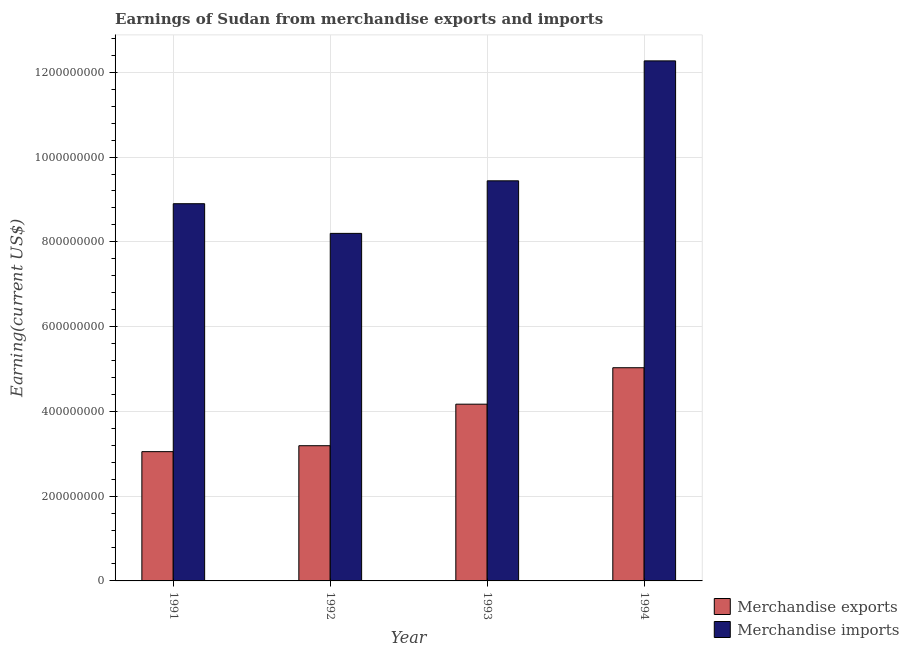How many groups of bars are there?
Provide a succinct answer. 4. Are the number of bars per tick equal to the number of legend labels?
Give a very brief answer. Yes. How many bars are there on the 4th tick from the right?
Provide a succinct answer. 2. What is the label of the 4th group of bars from the left?
Provide a short and direct response. 1994. What is the earnings from merchandise exports in 1993?
Provide a short and direct response. 4.17e+08. Across all years, what is the maximum earnings from merchandise exports?
Keep it short and to the point. 5.03e+08. Across all years, what is the minimum earnings from merchandise exports?
Offer a terse response. 3.05e+08. In which year was the earnings from merchandise exports maximum?
Offer a very short reply. 1994. What is the total earnings from merchandise exports in the graph?
Provide a short and direct response. 1.54e+09. What is the difference between the earnings from merchandise imports in 1991 and that in 1994?
Make the answer very short. -3.37e+08. What is the difference between the earnings from merchandise imports in 1991 and the earnings from merchandise exports in 1993?
Your answer should be compact. -5.40e+07. What is the average earnings from merchandise imports per year?
Provide a short and direct response. 9.70e+08. What is the ratio of the earnings from merchandise exports in 1993 to that in 1994?
Make the answer very short. 0.83. Is the earnings from merchandise exports in 1991 less than that in 1992?
Give a very brief answer. Yes. Is the difference between the earnings from merchandise exports in 1993 and 1994 greater than the difference between the earnings from merchandise imports in 1993 and 1994?
Provide a short and direct response. No. What is the difference between the highest and the second highest earnings from merchandise imports?
Ensure brevity in your answer.  2.83e+08. What is the difference between the highest and the lowest earnings from merchandise imports?
Your answer should be compact. 4.07e+08. Is the sum of the earnings from merchandise exports in 1993 and 1994 greater than the maximum earnings from merchandise imports across all years?
Your response must be concise. Yes. What does the 1st bar from the left in 1991 represents?
Your answer should be very brief. Merchandise exports. How many bars are there?
Ensure brevity in your answer.  8. What is the difference between two consecutive major ticks on the Y-axis?
Keep it short and to the point. 2.00e+08. Does the graph contain any zero values?
Offer a terse response. No. Where does the legend appear in the graph?
Make the answer very short. Bottom right. How many legend labels are there?
Provide a succinct answer. 2. How are the legend labels stacked?
Ensure brevity in your answer.  Vertical. What is the title of the graph?
Provide a short and direct response. Earnings of Sudan from merchandise exports and imports. What is the label or title of the X-axis?
Offer a very short reply. Year. What is the label or title of the Y-axis?
Provide a short and direct response. Earning(current US$). What is the Earning(current US$) in Merchandise exports in 1991?
Provide a succinct answer. 3.05e+08. What is the Earning(current US$) of Merchandise imports in 1991?
Give a very brief answer. 8.90e+08. What is the Earning(current US$) of Merchandise exports in 1992?
Your response must be concise. 3.19e+08. What is the Earning(current US$) in Merchandise imports in 1992?
Offer a terse response. 8.20e+08. What is the Earning(current US$) of Merchandise exports in 1993?
Provide a short and direct response. 4.17e+08. What is the Earning(current US$) of Merchandise imports in 1993?
Ensure brevity in your answer.  9.44e+08. What is the Earning(current US$) in Merchandise exports in 1994?
Offer a very short reply. 5.03e+08. What is the Earning(current US$) of Merchandise imports in 1994?
Offer a terse response. 1.23e+09. Across all years, what is the maximum Earning(current US$) in Merchandise exports?
Make the answer very short. 5.03e+08. Across all years, what is the maximum Earning(current US$) in Merchandise imports?
Ensure brevity in your answer.  1.23e+09. Across all years, what is the minimum Earning(current US$) of Merchandise exports?
Make the answer very short. 3.05e+08. Across all years, what is the minimum Earning(current US$) of Merchandise imports?
Offer a terse response. 8.20e+08. What is the total Earning(current US$) of Merchandise exports in the graph?
Offer a very short reply. 1.54e+09. What is the total Earning(current US$) in Merchandise imports in the graph?
Provide a short and direct response. 3.88e+09. What is the difference between the Earning(current US$) of Merchandise exports in 1991 and that in 1992?
Provide a succinct answer. -1.40e+07. What is the difference between the Earning(current US$) of Merchandise imports in 1991 and that in 1992?
Provide a short and direct response. 7.00e+07. What is the difference between the Earning(current US$) of Merchandise exports in 1991 and that in 1993?
Make the answer very short. -1.12e+08. What is the difference between the Earning(current US$) in Merchandise imports in 1991 and that in 1993?
Your response must be concise. -5.40e+07. What is the difference between the Earning(current US$) of Merchandise exports in 1991 and that in 1994?
Your response must be concise. -1.98e+08. What is the difference between the Earning(current US$) of Merchandise imports in 1991 and that in 1994?
Give a very brief answer. -3.37e+08. What is the difference between the Earning(current US$) of Merchandise exports in 1992 and that in 1993?
Your answer should be very brief. -9.80e+07. What is the difference between the Earning(current US$) in Merchandise imports in 1992 and that in 1993?
Provide a succinct answer. -1.24e+08. What is the difference between the Earning(current US$) in Merchandise exports in 1992 and that in 1994?
Your answer should be very brief. -1.84e+08. What is the difference between the Earning(current US$) of Merchandise imports in 1992 and that in 1994?
Your answer should be compact. -4.07e+08. What is the difference between the Earning(current US$) in Merchandise exports in 1993 and that in 1994?
Ensure brevity in your answer.  -8.60e+07. What is the difference between the Earning(current US$) of Merchandise imports in 1993 and that in 1994?
Your answer should be very brief. -2.83e+08. What is the difference between the Earning(current US$) in Merchandise exports in 1991 and the Earning(current US$) in Merchandise imports in 1992?
Offer a terse response. -5.15e+08. What is the difference between the Earning(current US$) of Merchandise exports in 1991 and the Earning(current US$) of Merchandise imports in 1993?
Offer a very short reply. -6.39e+08. What is the difference between the Earning(current US$) of Merchandise exports in 1991 and the Earning(current US$) of Merchandise imports in 1994?
Your response must be concise. -9.22e+08. What is the difference between the Earning(current US$) in Merchandise exports in 1992 and the Earning(current US$) in Merchandise imports in 1993?
Provide a short and direct response. -6.25e+08. What is the difference between the Earning(current US$) of Merchandise exports in 1992 and the Earning(current US$) of Merchandise imports in 1994?
Provide a succinct answer. -9.08e+08. What is the difference between the Earning(current US$) of Merchandise exports in 1993 and the Earning(current US$) of Merchandise imports in 1994?
Provide a short and direct response. -8.10e+08. What is the average Earning(current US$) in Merchandise exports per year?
Keep it short and to the point. 3.86e+08. What is the average Earning(current US$) in Merchandise imports per year?
Make the answer very short. 9.70e+08. In the year 1991, what is the difference between the Earning(current US$) of Merchandise exports and Earning(current US$) of Merchandise imports?
Your answer should be very brief. -5.85e+08. In the year 1992, what is the difference between the Earning(current US$) in Merchandise exports and Earning(current US$) in Merchandise imports?
Your answer should be very brief. -5.01e+08. In the year 1993, what is the difference between the Earning(current US$) of Merchandise exports and Earning(current US$) of Merchandise imports?
Keep it short and to the point. -5.27e+08. In the year 1994, what is the difference between the Earning(current US$) of Merchandise exports and Earning(current US$) of Merchandise imports?
Provide a succinct answer. -7.24e+08. What is the ratio of the Earning(current US$) of Merchandise exports in 1991 to that in 1992?
Your answer should be compact. 0.96. What is the ratio of the Earning(current US$) of Merchandise imports in 1991 to that in 1992?
Keep it short and to the point. 1.09. What is the ratio of the Earning(current US$) in Merchandise exports in 1991 to that in 1993?
Offer a very short reply. 0.73. What is the ratio of the Earning(current US$) in Merchandise imports in 1991 to that in 1993?
Keep it short and to the point. 0.94. What is the ratio of the Earning(current US$) of Merchandise exports in 1991 to that in 1994?
Your response must be concise. 0.61. What is the ratio of the Earning(current US$) of Merchandise imports in 1991 to that in 1994?
Your response must be concise. 0.73. What is the ratio of the Earning(current US$) of Merchandise exports in 1992 to that in 1993?
Ensure brevity in your answer.  0.77. What is the ratio of the Earning(current US$) in Merchandise imports in 1992 to that in 1993?
Give a very brief answer. 0.87. What is the ratio of the Earning(current US$) in Merchandise exports in 1992 to that in 1994?
Ensure brevity in your answer.  0.63. What is the ratio of the Earning(current US$) in Merchandise imports in 1992 to that in 1994?
Give a very brief answer. 0.67. What is the ratio of the Earning(current US$) of Merchandise exports in 1993 to that in 1994?
Provide a succinct answer. 0.83. What is the ratio of the Earning(current US$) in Merchandise imports in 1993 to that in 1994?
Keep it short and to the point. 0.77. What is the difference between the highest and the second highest Earning(current US$) of Merchandise exports?
Offer a terse response. 8.60e+07. What is the difference between the highest and the second highest Earning(current US$) of Merchandise imports?
Offer a very short reply. 2.83e+08. What is the difference between the highest and the lowest Earning(current US$) of Merchandise exports?
Offer a terse response. 1.98e+08. What is the difference between the highest and the lowest Earning(current US$) in Merchandise imports?
Give a very brief answer. 4.07e+08. 